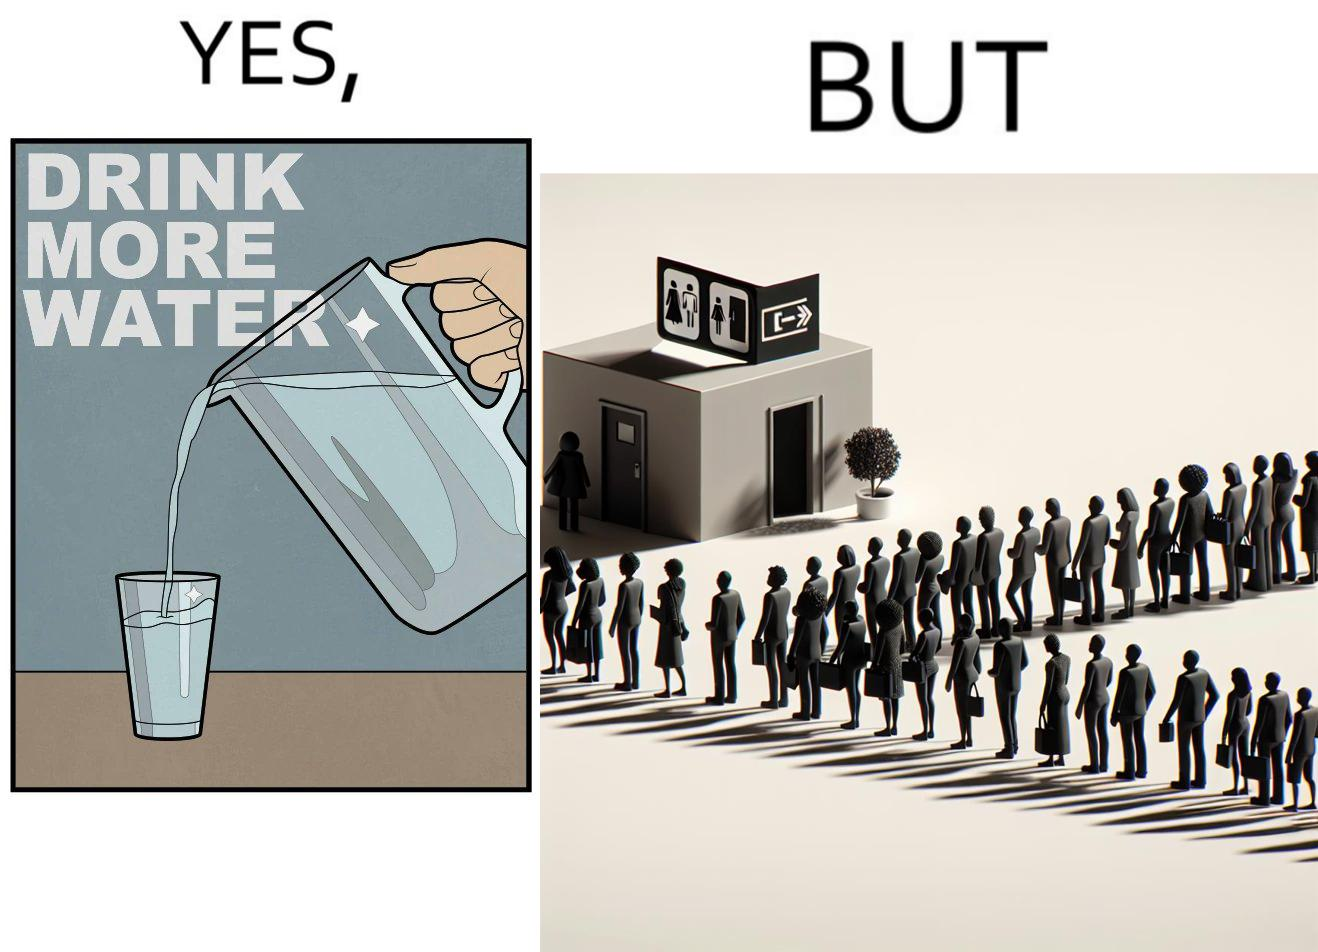Explain the humor or irony in this image. The image is ironical, as the message "Drink more water" is meant to improve health, but in turn, it would lead to longer queues in front of public toilets, leading to people holding urine for longer periods, in turn leading to deterioration in health. 